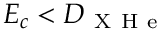Convert formula to latex. <formula><loc_0><loc_0><loc_500><loc_500>E _ { c } < D _ { X H e }</formula> 